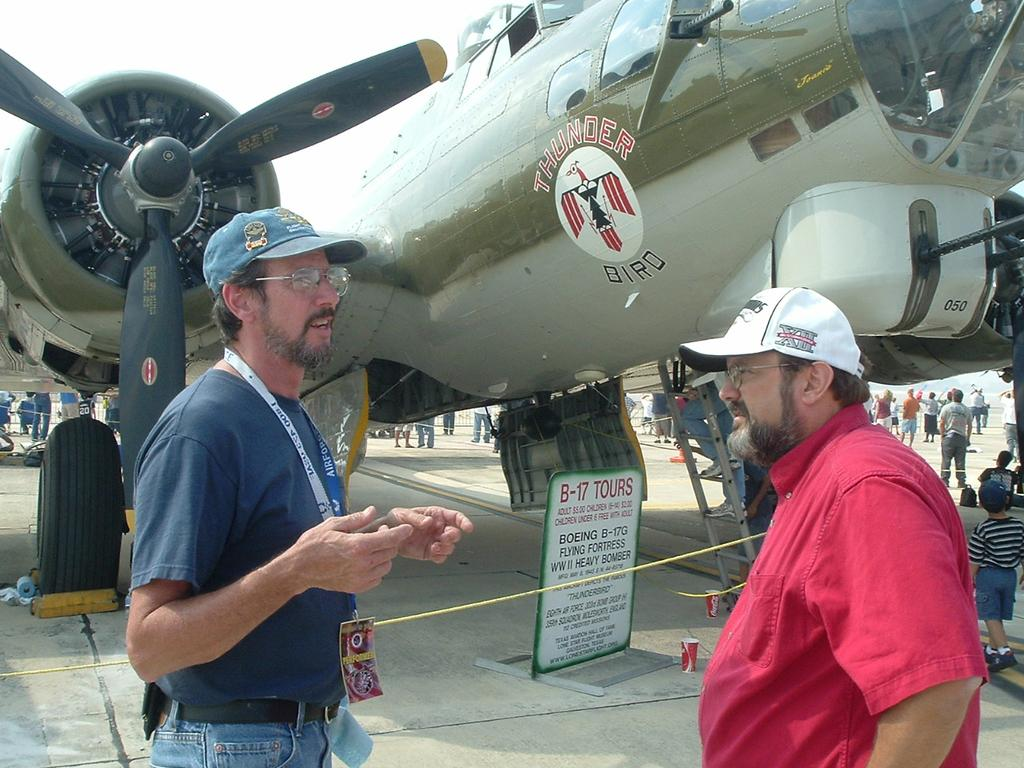<image>
Present a compact description of the photo's key features. Two middle aged men stand in front of the Thunder Bird Airplane talking. 